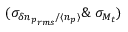Convert formula to latex. <formula><loc_0><loc_0><loc_500><loc_500>( \sigma _ { \delta { n _ { p } } _ { r m s } / \langle n _ { p } \rangle } \& \ \sigma _ { M _ { t } } )</formula> 